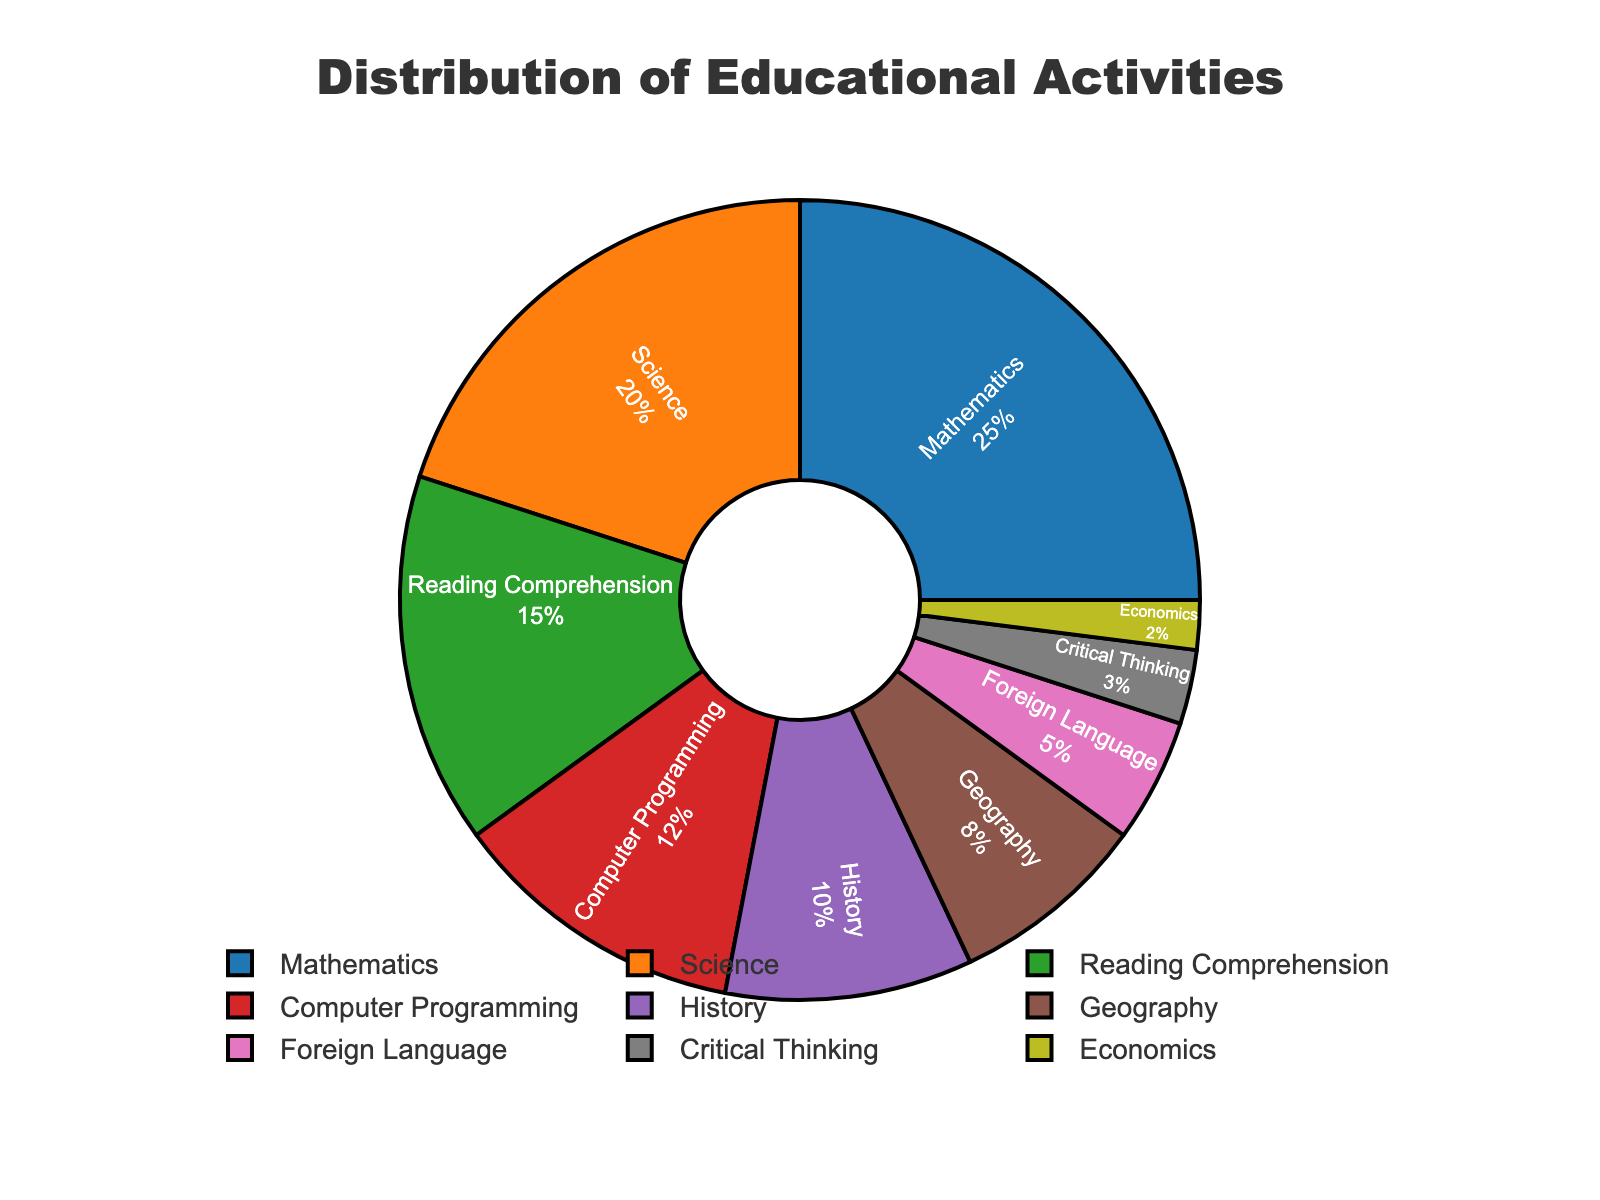Which subject has the highest percentage of educational activities allocated? Mathematics has the highest percentage of educational activities allocated, which is shown as 25% on the pie chart.
Answer: Mathematics Which subject constitutes the smallest portion of the educational activities? Economics constitutes the smallest portion of the educational activities, represented as 2% in the pie chart.
Answer: Economics How much more percentage is dedicated to Mathematics compared to Science? Mathematics is 25% and Science is 20%. The difference is calculated as 25% - 20% = 5%.
Answer: 5% What is the combined percentage of activities dedicated to Reading Comprehension, Computer Programming, and History? Reading Comprehension is 15%, Computer Programming is 12%, and History is 10%. The combined percentage is 15% + 12% + 10% = 37%.
Answer: 37% Is the percentage of activities for Foreign Language greater than the combined percentage for Critical Thinking and Economics? Foreign Language is 5%, while Critical Thinking and Economics together are 3% + 2% = 5%. The two values are equal.
Answer: No How does the percentage for Geography compare to that for History? Geography has 8% while History has 10%. History has a higher percentage than Geography by 2%.
Answer: History has 2% more What is the second most allocated educational activity for children? The second most allocated educational activity for children is Science, with 20%.
Answer: Science Calculate the total percentage of activities dedicated to STEM subjects (Mathematics, Science, and Computer Programming). Mathematics is 25%, Science is 20%, and Computer Programming is 12%. The total percentage is 25% + 20% + 12% = 57%.
Answer: 57% Which educational activity has a darker shade of blue, Mathematics or Foreign Language? Based on typical color schemes, Mathematics is usually represented with a darker shade of blue compared to Foreign Language on the pie chart.
Answer: Mathematics What is the difference between the combined percentage of Computer Programming and Critical Thinking compared to that of Reading Comprehension? Computer Programming is 12%, Critical Thinking is 3%, so combined is 12% + 3% = 15%. Reading Comprehension is also 15%. The difference is 15% - 15% = 0%.
Answer: 0% 